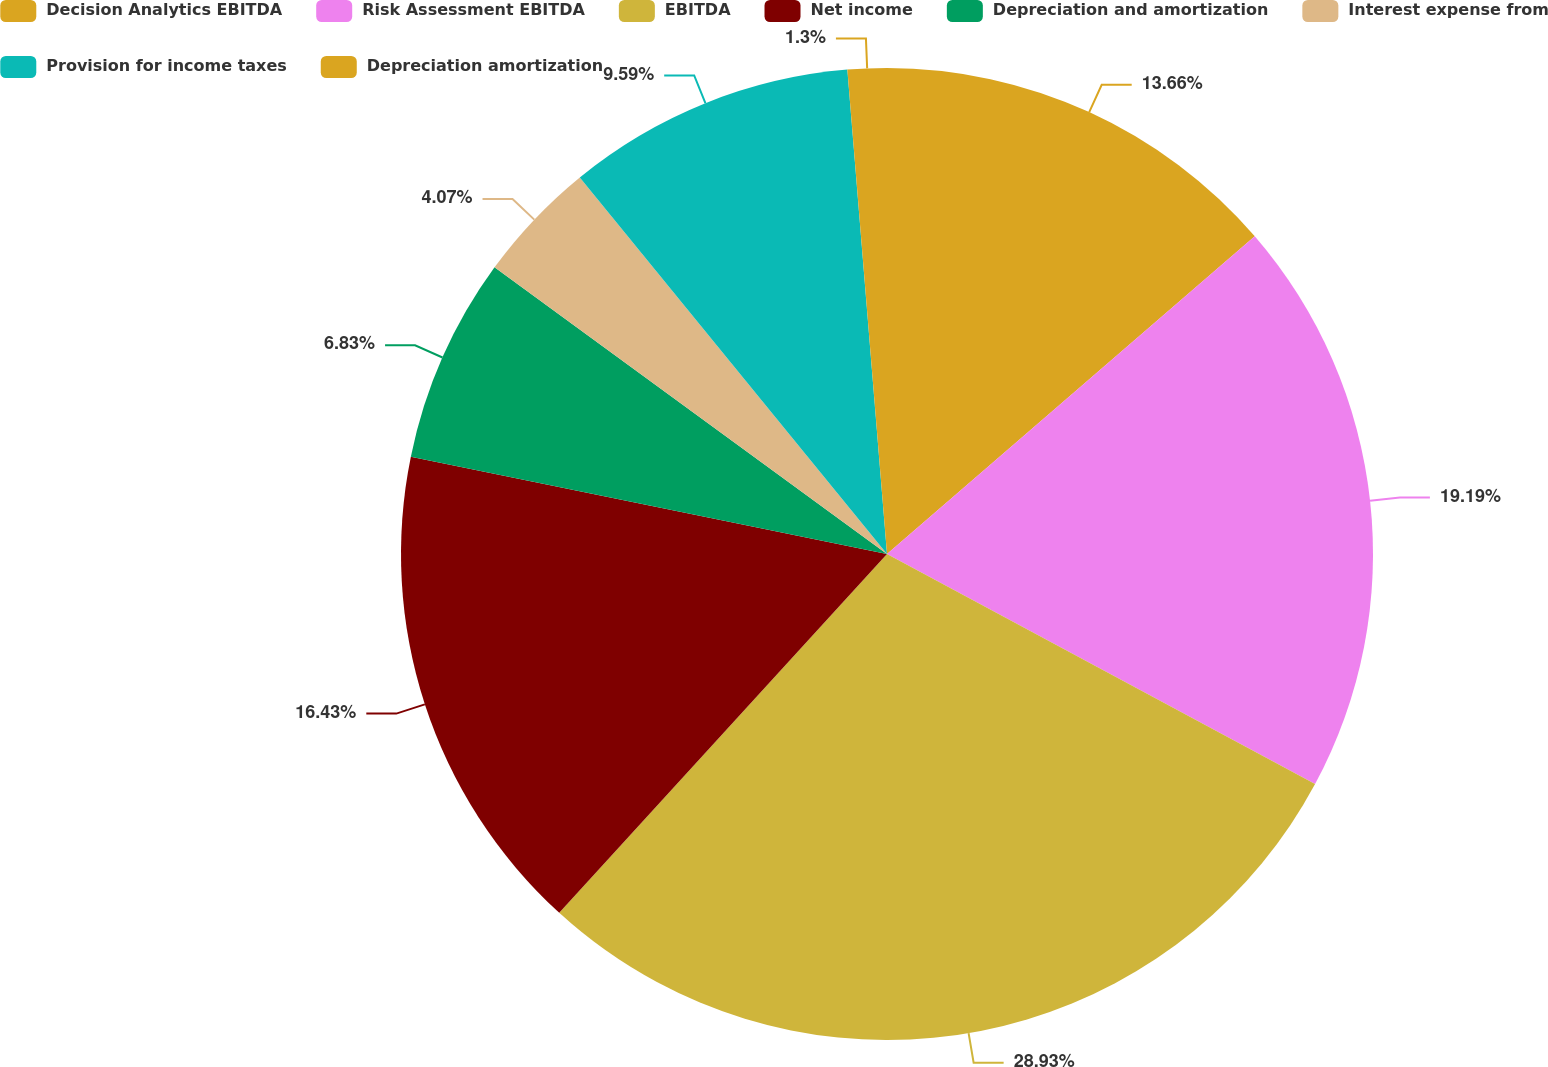<chart> <loc_0><loc_0><loc_500><loc_500><pie_chart><fcel>Decision Analytics EBITDA<fcel>Risk Assessment EBITDA<fcel>EBITDA<fcel>Net income<fcel>Depreciation and amortization<fcel>Interest expense from<fcel>Provision for income taxes<fcel>Depreciation amortization<nl><fcel>13.66%<fcel>19.19%<fcel>28.93%<fcel>16.43%<fcel>6.83%<fcel>4.07%<fcel>9.59%<fcel>1.3%<nl></chart> 